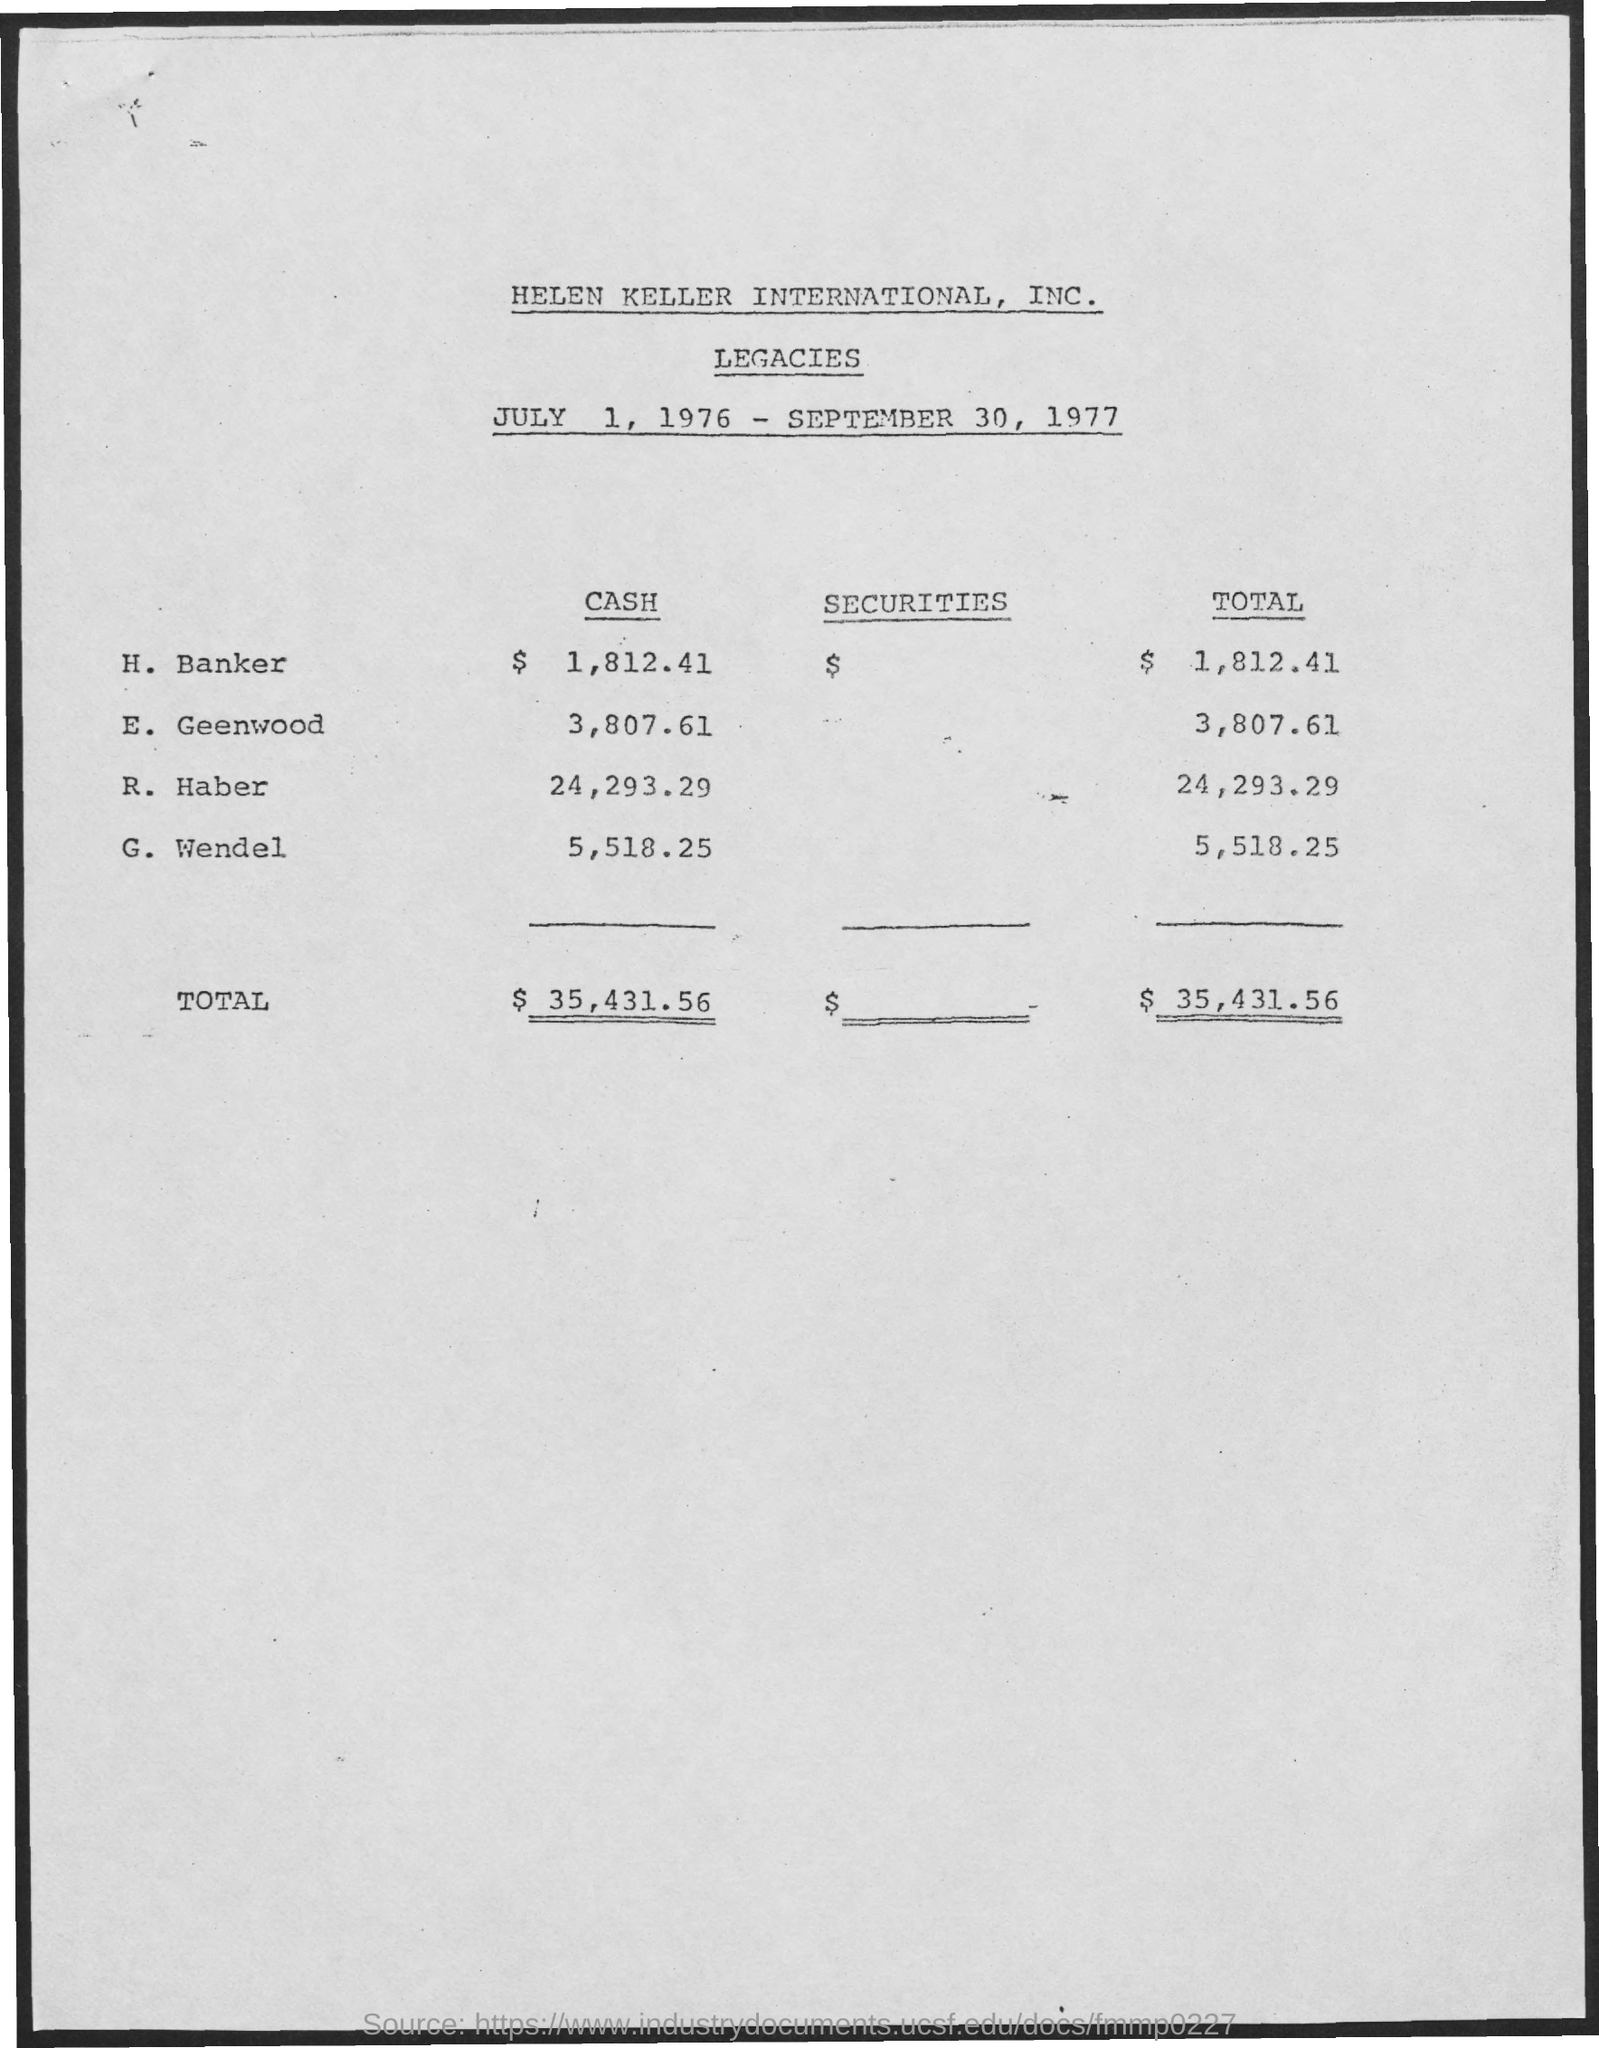Draw attention to some important aspects in this diagram. The total of Haber is 24,293.29. 